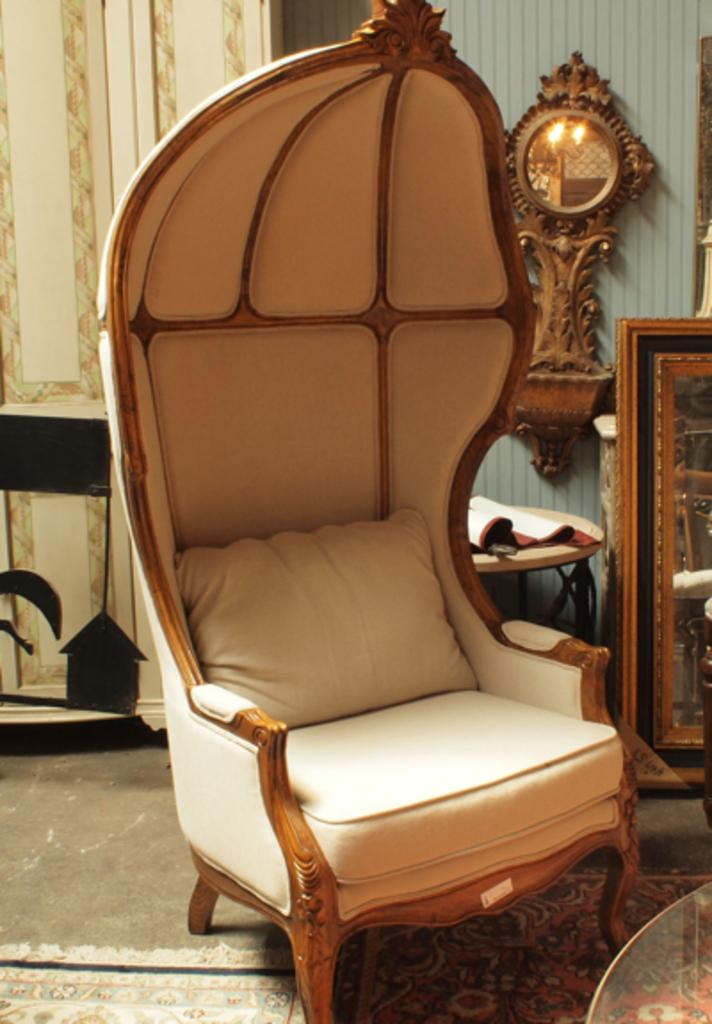What type of furniture is in the image? There is a couch in the image. What color is the couch? The couch is cream-colored. What can be seen in the background of the image? There is a frame and a clock in the background of the image. How is the clock positioned in the image? The clock is attached to some object in the background. What type of paper is being used to make the trousers in the image? There is no paper or trousers present in the image; it features a couch, a frame, and a clock. Can you tell me the color of the pear in the image? There is no pear present in the image. 